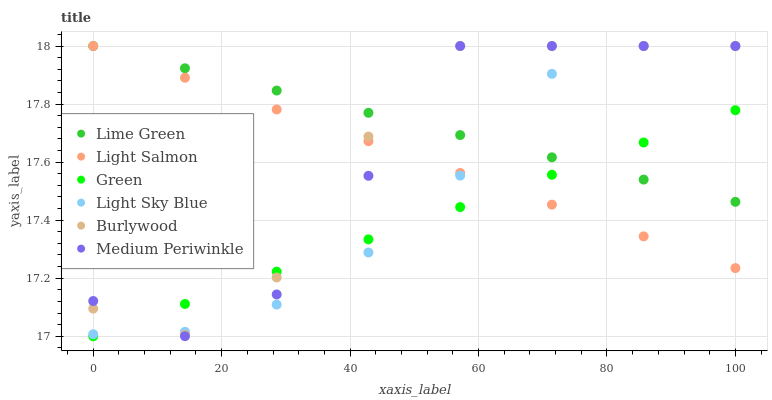Does Green have the minimum area under the curve?
Answer yes or no. Yes. Does Lime Green have the maximum area under the curve?
Answer yes or no. Yes. Does Burlywood have the minimum area under the curve?
Answer yes or no. No. Does Burlywood have the maximum area under the curve?
Answer yes or no. No. Is Green the smoothest?
Answer yes or no. Yes. Is Burlywood the roughest?
Answer yes or no. Yes. Is Medium Periwinkle the smoothest?
Answer yes or no. No. Is Medium Periwinkle the roughest?
Answer yes or no. No. Does Green have the lowest value?
Answer yes or no. Yes. Does Burlywood have the lowest value?
Answer yes or no. No. Does Lime Green have the highest value?
Answer yes or no. Yes. Does Green have the highest value?
Answer yes or no. No. Does Burlywood intersect Green?
Answer yes or no. Yes. Is Burlywood less than Green?
Answer yes or no. No. Is Burlywood greater than Green?
Answer yes or no. No. 